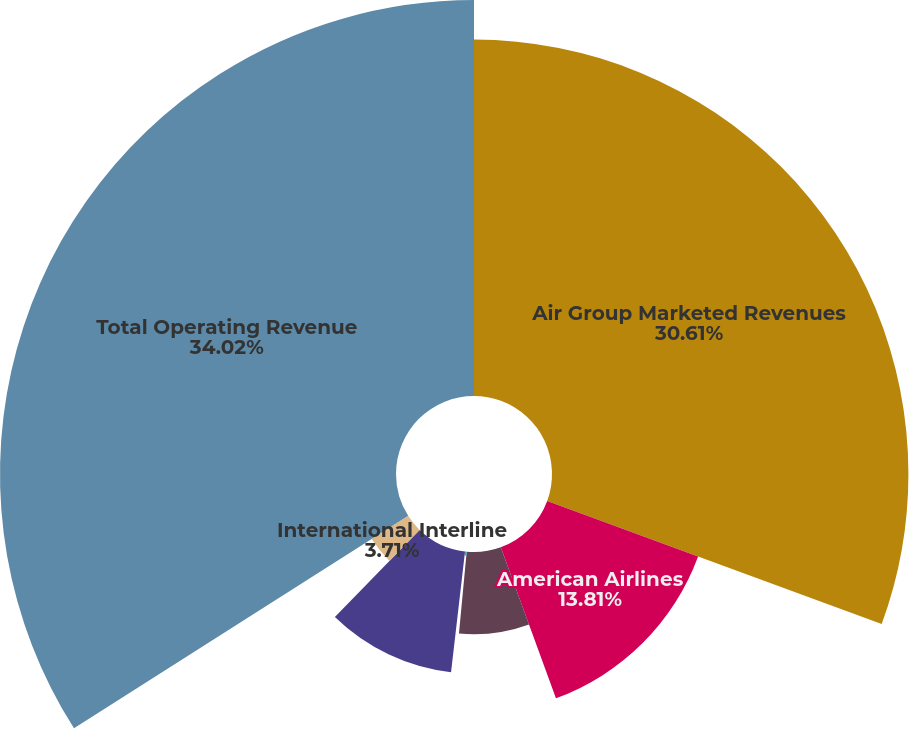<chart> <loc_0><loc_0><loc_500><loc_500><pie_chart><fcel>Air Group Marketed Revenues<fcel>American Airlines<fcel>Delta Air Lines<fcel>Others<fcel>Domestic Interline<fcel>International Interline<fcel>Total Operating Revenue<nl><fcel>30.61%<fcel>13.81%<fcel>7.07%<fcel>0.34%<fcel>10.44%<fcel>3.71%<fcel>34.01%<nl></chart> 